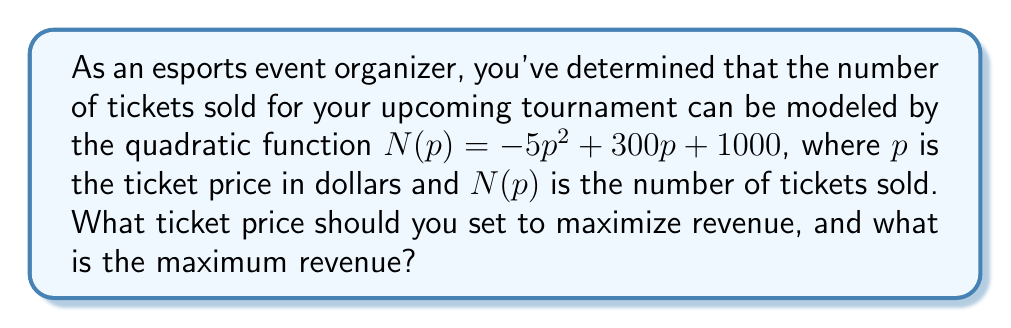Can you answer this question? 1) The revenue function $R(p)$ is the product of the price per ticket and the number of tickets sold:
   $R(p) = p \cdot N(p) = p(-5p^2 + 300p + 1000)$

2) Expand the revenue function:
   $R(p) = -5p^3 + 300p^2 + 1000p$

3) To find the maximum revenue, we need to find the derivative of $R(p)$ and set it to zero:
   $R'(p) = -15p^2 + 600p + 1000$

4) Set $R'(p) = 0$:
   $-15p^2 + 600p + 1000 = 0$

5) This is a quadratic equation. We can solve it using the quadratic formula:
   $p = \frac{-b \pm \sqrt{b^2 - 4ac}}{2a}$

   Where $a = -15$, $b = 600$, and $c = 1000$

6) Plugging in these values:
   $p = \frac{-600 \pm \sqrt{600^2 - 4(-15)(1000)}}{2(-15)}$

7) Simplify:
   $p = \frac{-600 \pm \sqrt{360000 + 60000}}{-30} = \frac{-600 \pm \sqrt{420000}}{-30}$

8) Solve:
   $p \approx 31.62$ or $p \approx 21.05$

9) The second derivative of $R(p)$ is $R''(p) = -30p + 600$. At $p = 31.62$, $R''(p) < 0$, indicating a maximum.

10) Therefore, the optimal price is $\$31.62$ (rounded to the nearest cent).

11) To find the maximum revenue, plug this price back into the original revenue function:
    $R(31.62) = -5(31.62)^3 + 300(31.62)^2 + 1000(31.62) \approx 11,856.33$
Answer: Optimal price: $\$31.62$; Maximum revenue: $\$11,856.33$ 